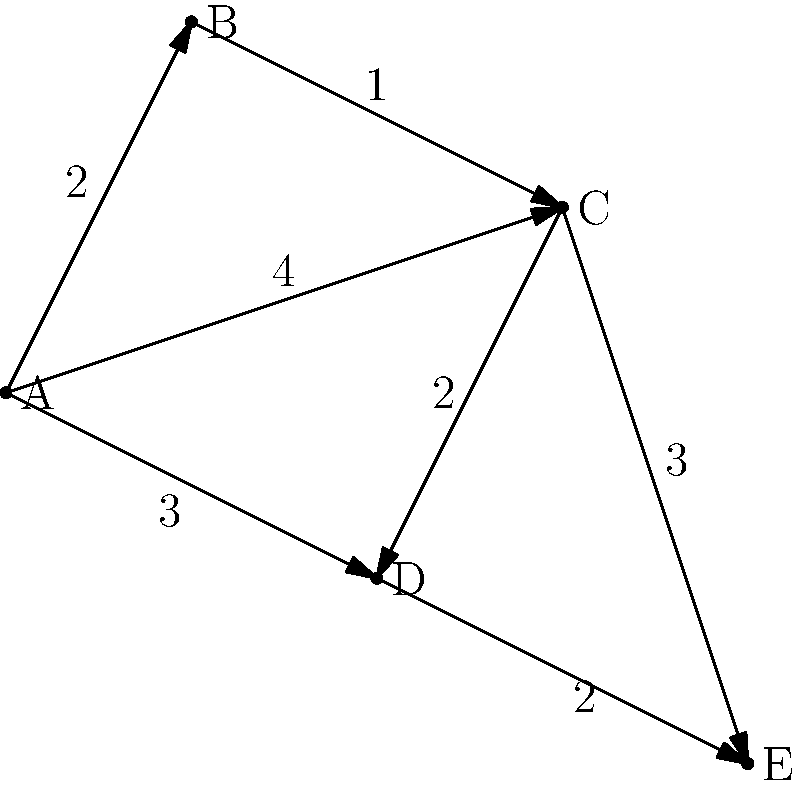Given the graph representing distribution routes for eco-friendly dyes, where vertices represent cities and edge weights represent transportation costs in millions of dollars, what is the minimum cost to distribute the dyes from city A to all other cities using Dijkstra's algorithm? To solve this problem using Dijkstra's algorithm, we'll follow these steps:

1) Initialize:
   - Set distance to A as 0
   - Set distances to all other vertices as infinity
   - Set all vertices as unvisited

2) For the current vertex (starting with A), consider all unvisited neighbors and calculate their tentative distances.

3) When we're done considering all neighbors of the current vertex, mark it as visited.

4) If all vertices are visited, finish. Otherwise, select the unvisited vertex with the smallest tentative distance and set it as the new current vertex. Go back to step 2.

Applying the algorithm:

- Start at A (distance = 0)
- Consider B (A to B = 2), C (A to C = 4), D (A to D = 3)
- Mark A as visited
- Move to B (smallest distance from A)
- Update: C (B to C = 1, total 3 < 4), D unchanged
- Mark B as visited
- Move to C (next smallest distance)
- Update: D (C to D = 2, total 5 > 3, no change), E (C to E = 3, total 6)
- Mark C as visited
- Move to D (next smallest distance)
- Update: E (D to E = 2, total 5 < 6)
- Mark D as visited
- Move to E (last unvisited vertex)
- Mark E as visited

Final shortest distances from A:
B: 2
C: 3
D: 3
E: 5

The total cost is the sum of these distances: $2 + 3 + 3 + 5 = 13$ million dollars.
Answer: $13 million 